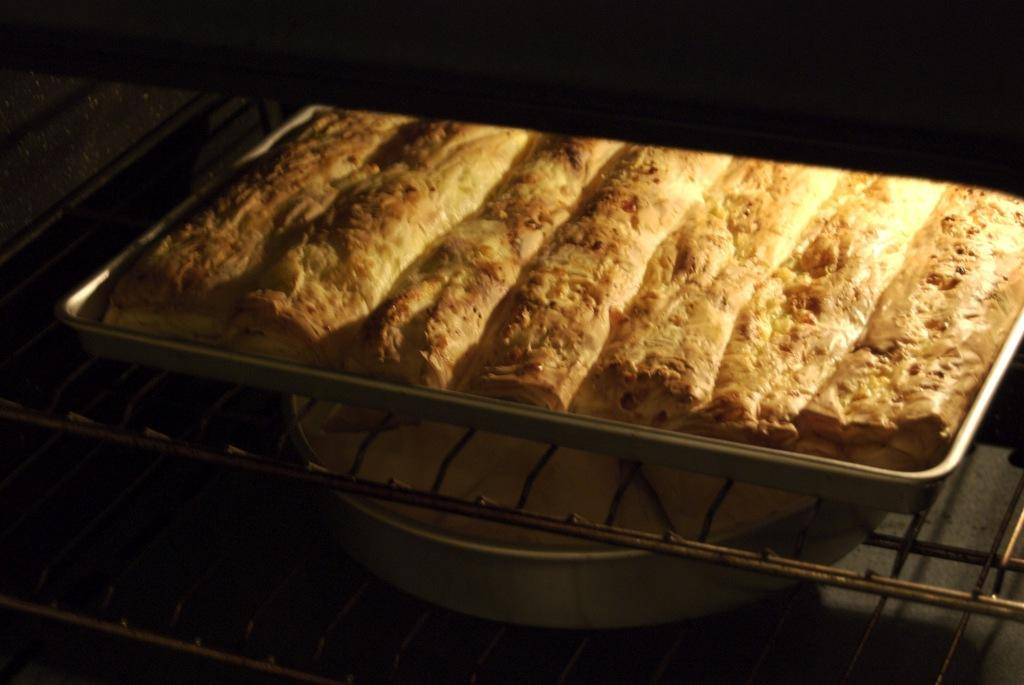What is on the baking trays in the image? There are food items on the baking trays in the image. How are the food items arranged or prepared? The food is on grills in the image. What can be observed about the color of the image's sides? The left and right sides of the image are black in color. What type of powder is being used to create the grill marks on the food in the image? There is no mention of powder being used to create grill marks on the food in the image. 